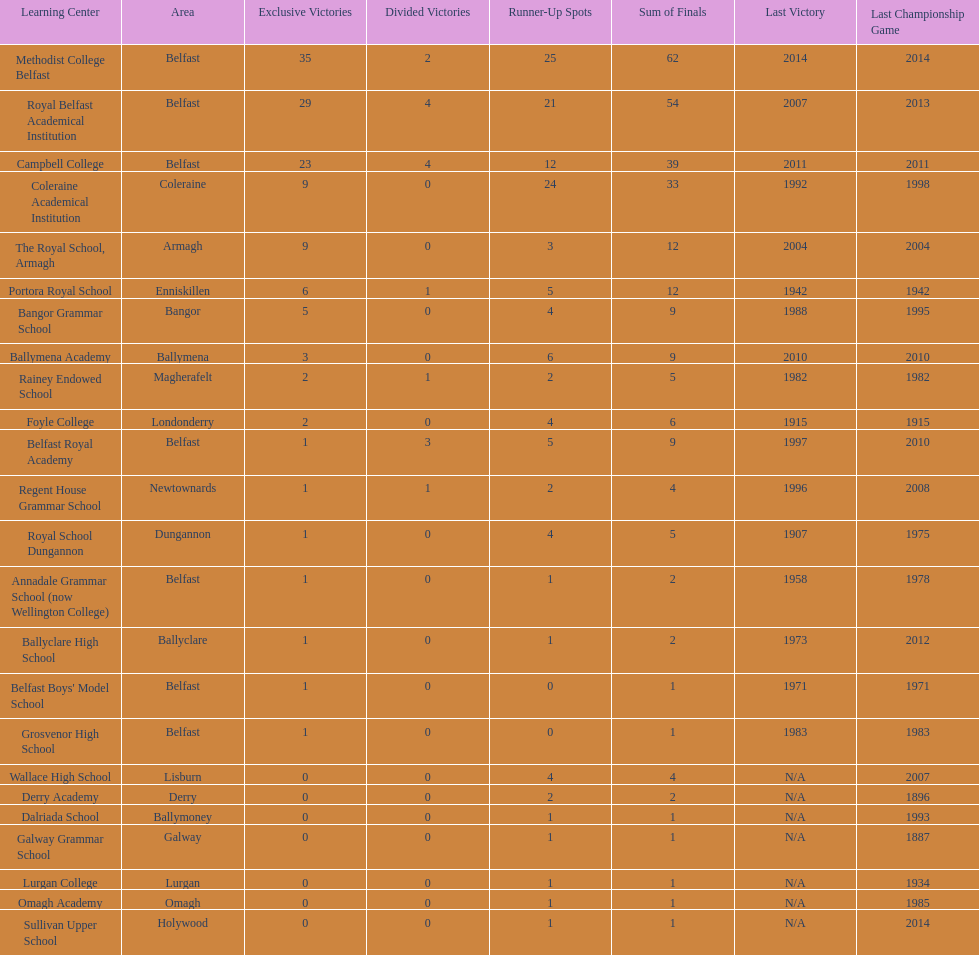Did belfast royal academy have more or less total finals than ballyclare high school? More. 